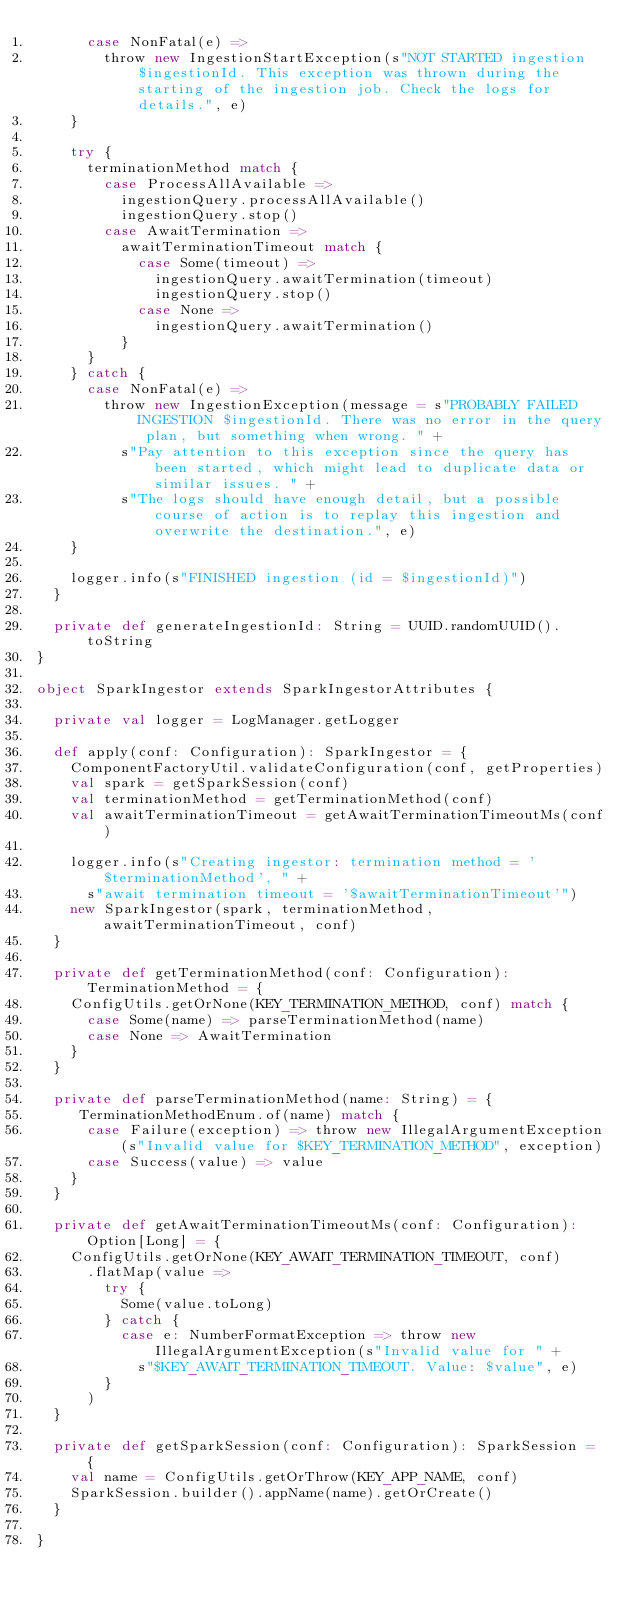Convert code to text. <code><loc_0><loc_0><loc_500><loc_500><_Scala_>      case NonFatal(e) =>
        throw new IngestionStartException(s"NOT STARTED ingestion $ingestionId. This exception was thrown during the starting of the ingestion job. Check the logs for details.", e)
    }

    try {
      terminationMethod match {
        case ProcessAllAvailable =>
          ingestionQuery.processAllAvailable()
          ingestionQuery.stop()
        case AwaitTermination =>
          awaitTerminationTimeout match {
            case Some(timeout) =>
              ingestionQuery.awaitTermination(timeout)
              ingestionQuery.stop()
            case None =>
              ingestionQuery.awaitTermination()
          }
      }
    } catch {
      case NonFatal(e) =>
        throw new IngestionException(message = s"PROBABLY FAILED INGESTION $ingestionId. There was no error in the query plan, but something when wrong. " +
          s"Pay attention to this exception since the query has been started, which might lead to duplicate data or similar issues. " +
          s"The logs should have enough detail, but a possible course of action is to replay this ingestion and overwrite the destination.", e)
    }

    logger.info(s"FINISHED ingestion (id = $ingestionId)")
  }

  private def generateIngestionId: String = UUID.randomUUID().toString
}

object SparkIngestor extends SparkIngestorAttributes {

  private val logger = LogManager.getLogger

  def apply(conf: Configuration): SparkIngestor = {
    ComponentFactoryUtil.validateConfiguration(conf, getProperties)
    val spark = getSparkSession(conf)
    val terminationMethod = getTerminationMethod(conf)
    val awaitTerminationTimeout = getAwaitTerminationTimeoutMs(conf)

    logger.info(s"Creating ingestor: termination method = '$terminationMethod', " +
      s"await termination timeout = '$awaitTerminationTimeout'")
    new SparkIngestor(spark, terminationMethod, awaitTerminationTimeout, conf)
  }

  private def getTerminationMethod(conf: Configuration): TerminationMethod = {
    ConfigUtils.getOrNone(KEY_TERMINATION_METHOD, conf) match {
      case Some(name) => parseTerminationMethod(name)
      case None => AwaitTermination
    }
  }

  private def parseTerminationMethod(name: String) = {
     TerminationMethodEnum.of(name) match {
      case Failure(exception) => throw new IllegalArgumentException(s"Invalid value for $KEY_TERMINATION_METHOD", exception)
      case Success(value) => value
    }
  }

  private def getAwaitTerminationTimeoutMs(conf: Configuration): Option[Long] = {
    ConfigUtils.getOrNone(KEY_AWAIT_TERMINATION_TIMEOUT, conf)
      .flatMap(value =>
        try {
          Some(value.toLong)
        } catch {
          case e: NumberFormatException => throw new IllegalArgumentException(s"Invalid value for " +
            s"$KEY_AWAIT_TERMINATION_TIMEOUT. Value: $value", e)
        }
      )
  }

  private def getSparkSession(conf: Configuration): SparkSession = {
    val name = ConfigUtils.getOrThrow(KEY_APP_NAME, conf)
    SparkSession.builder().appName(name).getOrCreate()
  }

}
</code> 